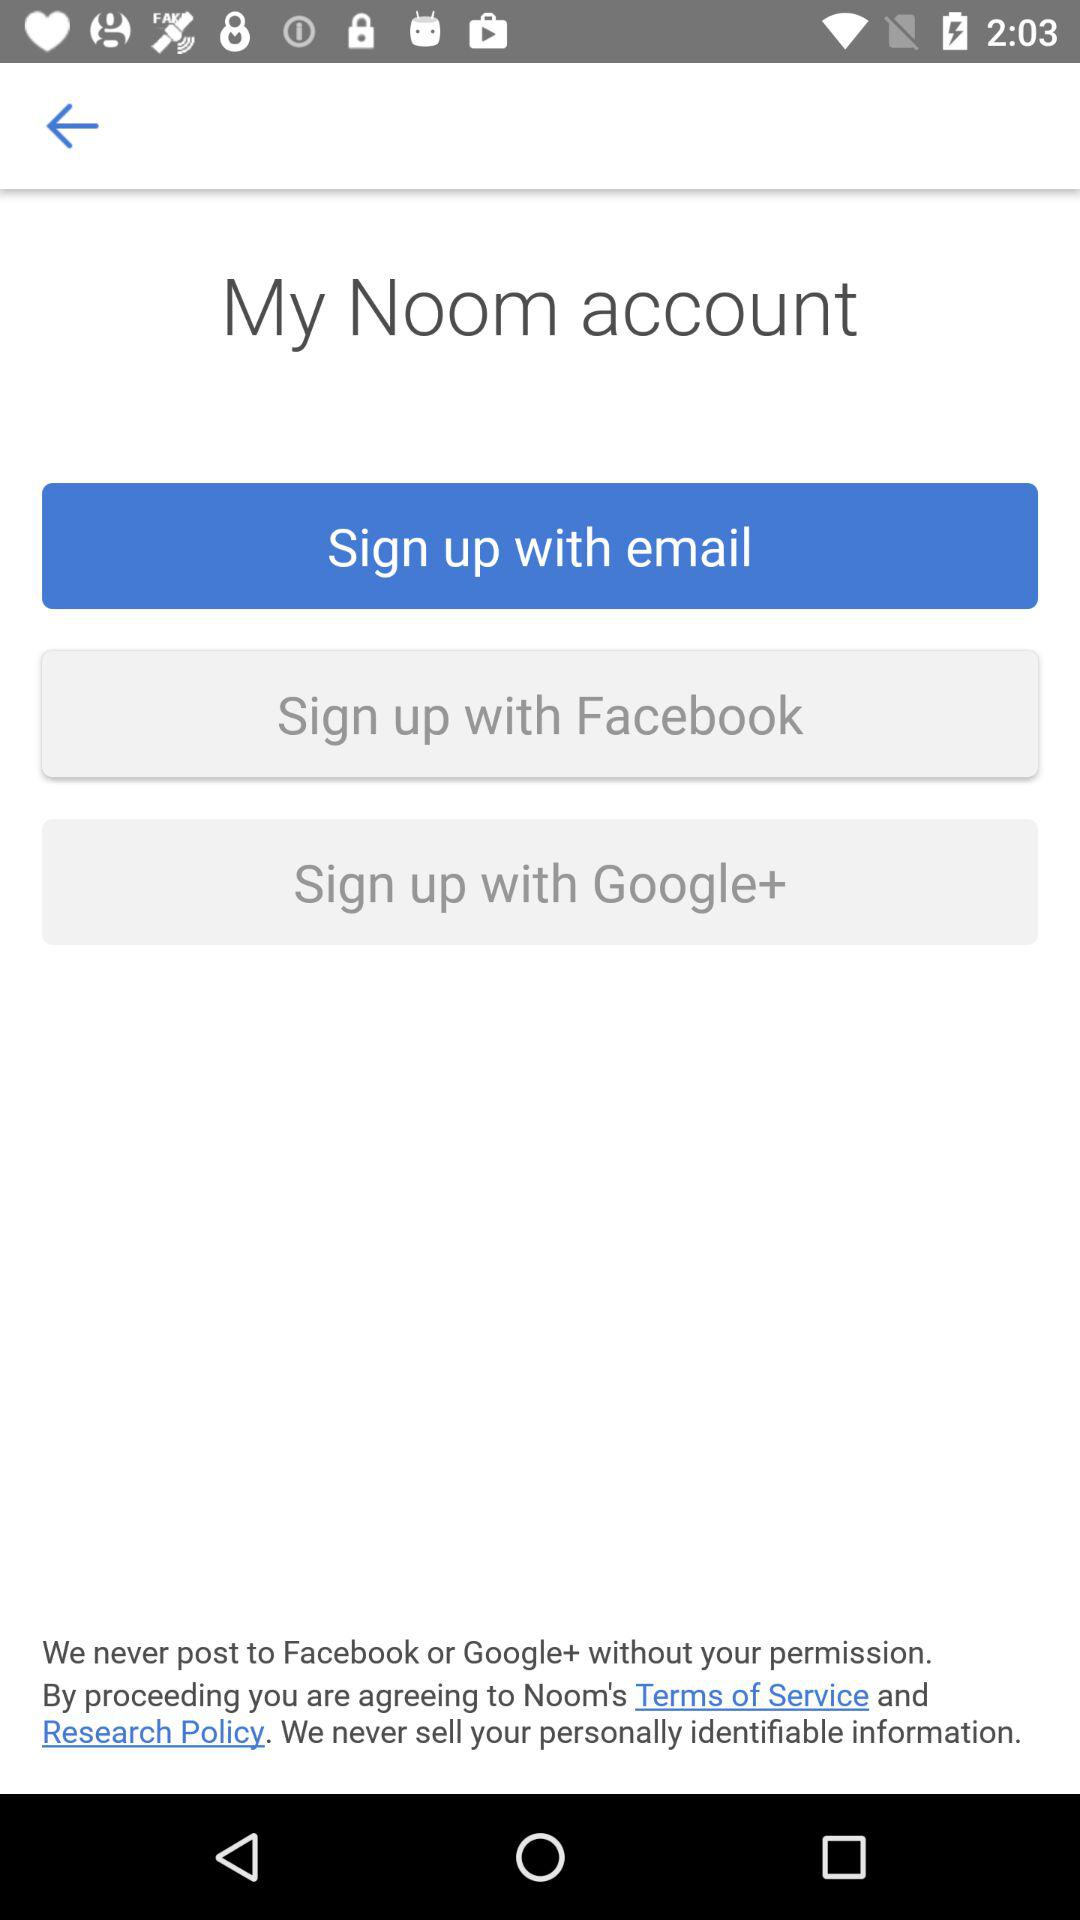Which option has been selected? The option that has been selected is "Sign up with email". 